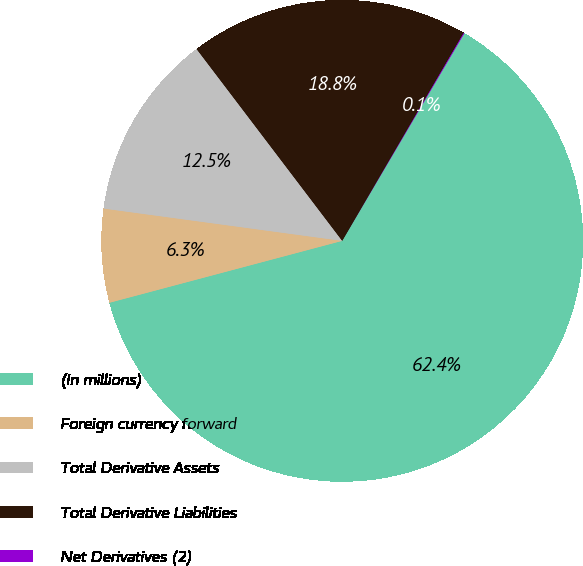Convert chart. <chart><loc_0><loc_0><loc_500><loc_500><pie_chart><fcel>(In millions)<fcel>Foreign currency forward<fcel>Total Derivative Assets<fcel>Total Derivative Liabilities<fcel>Net Derivatives (2)<nl><fcel>62.39%<fcel>6.28%<fcel>12.52%<fcel>18.75%<fcel>0.05%<nl></chart> 